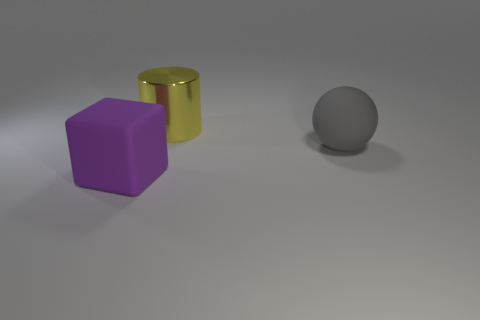How do the textures of the objects compare to each other? The surfaces of the objects exhibit different textures. The cube and the cylinder have a smooth and somewhat reflective texture, indicating a possible metallic or polished material. The sphere has a matte finish, absorbing more light and reflecting less, which might suggest a rougher texture compared to the others. 